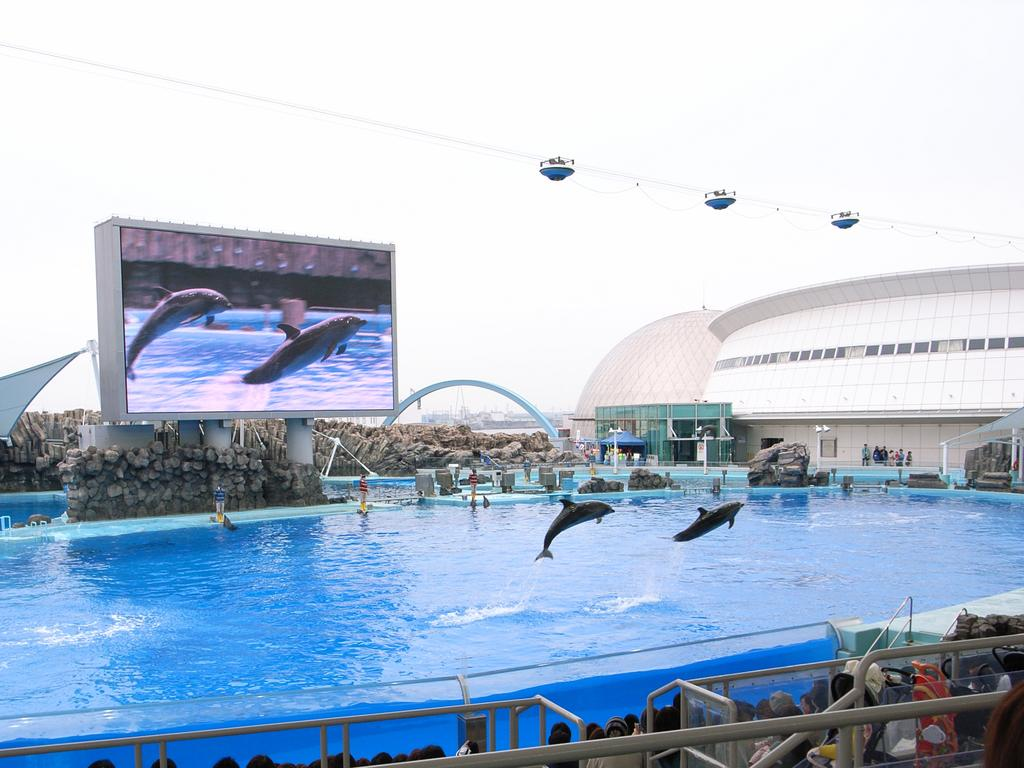What type of objects can be seen in the image? There are metal rods in the image. Can you describe the people in the image? There is a group of people in the image. What is visible in the water in the image? Dolphins are present in the water. What can be seen in the background of the image? There are rocks, a screen, cables, and buildings in the background of the image. What type of mind-reading abilities do the dolphins exhibit in the image? There is no indication in the image that the dolphins possess any mind-reading abilities. 